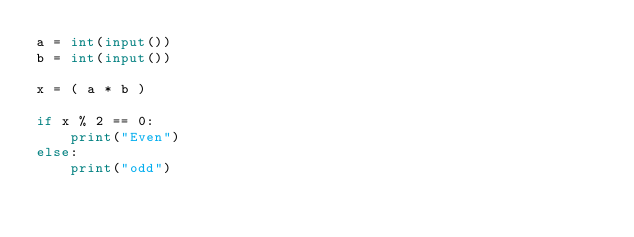<code> <loc_0><loc_0><loc_500><loc_500><_Python_>a = int(input())
b = int(input())

x = ( a * b )

if x % 2 == 0:
    print("Even")
else:
    print("odd")</code> 